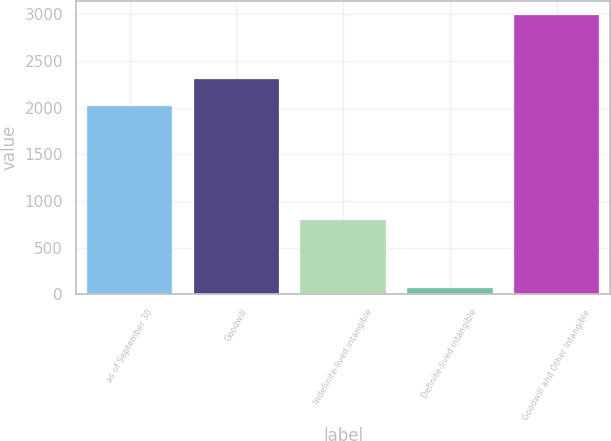<chart> <loc_0><loc_0><loc_500><loc_500><bar_chart><fcel>as of September 30<fcel>Goodwill<fcel>Indefinite-lived intangible<fcel>Definite-lived intangible<fcel>Goodwill and Other Intangible<nl><fcel>2019<fcel>2311.97<fcel>799.4<fcel>64.8<fcel>2994.5<nl></chart> 